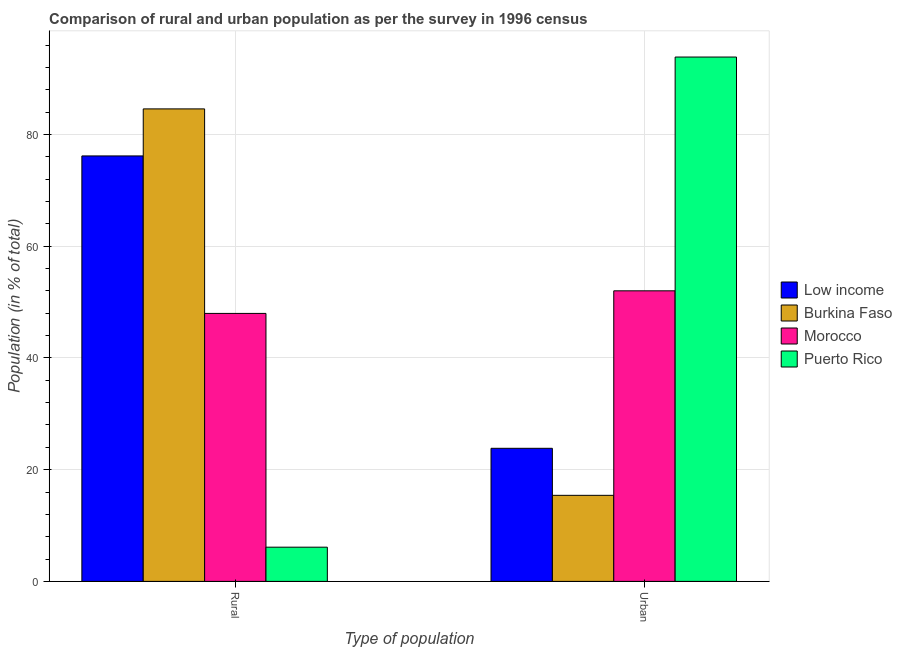How many different coloured bars are there?
Provide a succinct answer. 4. Are the number of bars per tick equal to the number of legend labels?
Offer a very short reply. Yes. Are the number of bars on each tick of the X-axis equal?
Ensure brevity in your answer.  Yes. How many bars are there on the 1st tick from the right?
Your answer should be compact. 4. What is the label of the 2nd group of bars from the left?
Offer a very short reply. Urban. What is the rural population in Puerto Rico?
Your response must be concise. 6.12. Across all countries, what is the maximum rural population?
Offer a terse response. 84.59. Across all countries, what is the minimum urban population?
Keep it short and to the point. 15.41. In which country was the rural population maximum?
Your answer should be compact. Burkina Faso. In which country was the rural population minimum?
Your answer should be very brief. Puerto Rico. What is the total urban population in the graph?
Your response must be concise. 185.13. What is the difference between the urban population in Low income and that in Burkina Faso?
Provide a short and direct response. 8.42. What is the difference between the urban population in Puerto Rico and the rural population in Low income?
Offer a very short reply. 17.7. What is the average urban population per country?
Offer a terse response. 46.28. What is the difference between the rural population and urban population in Morocco?
Give a very brief answer. -4.04. What is the ratio of the rural population in Morocco to that in Low income?
Keep it short and to the point. 0.63. In how many countries, is the rural population greater than the average rural population taken over all countries?
Make the answer very short. 2. What does the 2nd bar from the left in Rural represents?
Ensure brevity in your answer.  Burkina Faso. How many bars are there?
Ensure brevity in your answer.  8. Are all the bars in the graph horizontal?
Ensure brevity in your answer.  No. Are the values on the major ticks of Y-axis written in scientific E-notation?
Your answer should be compact. No. Does the graph contain any zero values?
Your answer should be very brief. No. Does the graph contain grids?
Ensure brevity in your answer.  Yes. Where does the legend appear in the graph?
Your answer should be very brief. Center right. What is the title of the graph?
Make the answer very short. Comparison of rural and urban population as per the survey in 1996 census. Does "Central African Republic" appear as one of the legend labels in the graph?
Give a very brief answer. No. What is the label or title of the X-axis?
Provide a succinct answer. Type of population. What is the label or title of the Y-axis?
Keep it short and to the point. Population (in % of total). What is the Population (in % of total) of Low income in Rural?
Make the answer very short. 76.17. What is the Population (in % of total) of Burkina Faso in Rural?
Your answer should be compact. 84.59. What is the Population (in % of total) in Morocco in Rural?
Offer a terse response. 47.98. What is the Population (in % of total) in Puerto Rico in Rural?
Provide a short and direct response. 6.12. What is the Population (in % of total) of Low income in Urban?
Provide a succinct answer. 23.83. What is the Population (in % of total) in Burkina Faso in Urban?
Make the answer very short. 15.41. What is the Population (in % of total) of Morocco in Urban?
Keep it short and to the point. 52.02. What is the Population (in % of total) of Puerto Rico in Urban?
Your answer should be very brief. 93.88. Across all Type of population, what is the maximum Population (in % of total) in Low income?
Offer a very short reply. 76.17. Across all Type of population, what is the maximum Population (in % of total) of Burkina Faso?
Offer a very short reply. 84.59. Across all Type of population, what is the maximum Population (in % of total) in Morocco?
Ensure brevity in your answer.  52.02. Across all Type of population, what is the maximum Population (in % of total) of Puerto Rico?
Ensure brevity in your answer.  93.88. Across all Type of population, what is the minimum Population (in % of total) in Low income?
Your answer should be very brief. 23.83. Across all Type of population, what is the minimum Population (in % of total) of Burkina Faso?
Give a very brief answer. 15.41. Across all Type of population, what is the minimum Population (in % of total) of Morocco?
Ensure brevity in your answer.  47.98. Across all Type of population, what is the minimum Population (in % of total) in Puerto Rico?
Ensure brevity in your answer.  6.12. What is the total Population (in % of total) in Burkina Faso in the graph?
Keep it short and to the point. 100. What is the difference between the Population (in % of total) of Low income in Rural and that in Urban?
Offer a very short reply. 52.35. What is the difference between the Population (in % of total) in Burkina Faso in Rural and that in Urban?
Offer a terse response. 69.19. What is the difference between the Population (in % of total) in Morocco in Rural and that in Urban?
Your answer should be very brief. -4.04. What is the difference between the Population (in % of total) in Puerto Rico in Rural and that in Urban?
Your answer should be compact. -87.75. What is the difference between the Population (in % of total) in Low income in Rural and the Population (in % of total) in Burkina Faso in Urban?
Your response must be concise. 60.77. What is the difference between the Population (in % of total) of Low income in Rural and the Population (in % of total) of Morocco in Urban?
Provide a succinct answer. 24.15. What is the difference between the Population (in % of total) in Low income in Rural and the Population (in % of total) in Puerto Rico in Urban?
Ensure brevity in your answer.  -17.7. What is the difference between the Population (in % of total) of Burkina Faso in Rural and the Population (in % of total) of Morocco in Urban?
Provide a short and direct response. 32.57. What is the difference between the Population (in % of total) in Burkina Faso in Rural and the Population (in % of total) in Puerto Rico in Urban?
Keep it short and to the point. -9.28. What is the difference between the Population (in % of total) in Morocco in Rural and the Population (in % of total) in Puerto Rico in Urban?
Provide a short and direct response. -45.9. What is the average Population (in % of total) of Burkina Faso per Type of population?
Ensure brevity in your answer.  50. What is the average Population (in % of total) in Morocco per Type of population?
Your answer should be compact. 50. What is the difference between the Population (in % of total) of Low income and Population (in % of total) of Burkina Faso in Rural?
Offer a terse response. -8.42. What is the difference between the Population (in % of total) of Low income and Population (in % of total) of Morocco in Rural?
Provide a short and direct response. 28.19. What is the difference between the Population (in % of total) of Low income and Population (in % of total) of Puerto Rico in Rural?
Provide a succinct answer. 70.05. What is the difference between the Population (in % of total) of Burkina Faso and Population (in % of total) of Morocco in Rural?
Provide a succinct answer. 36.62. What is the difference between the Population (in % of total) in Burkina Faso and Population (in % of total) in Puerto Rico in Rural?
Keep it short and to the point. 78.47. What is the difference between the Population (in % of total) in Morocco and Population (in % of total) in Puerto Rico in Rural?
Your response must be concise. 41.85. What is the difference between the Population (in % of total) of Low income and Population (in % of total) of Burkina Faso in Urban?
Provide a short and direct response. 8.42. What is the difference between the Population (in % of total) of Low income and Population (in % of total) of Morocco in Urban?
Keep it short and to the point. -28.19. What is the difference between the Population (in % of total) in Low income and Population (in % of total) in Puerto Rico in Urban?
Offer a very short reply. -70.05. What is the difference between the Population (in % of total) in Burkina Faso and Population (in % of total) in Morocco in Urban?
Your answer should be very brief. -36.62. What is the difference between the Population (in % of total) in Burkina Faso and Population (in % of total) in Puerto Rico in Urban?
Make the answer very short. -78.47. What is the difference between the Population (in % of total) of Morocco and Population (in % of total) of Puerto Rico in Urban?
Ensure brevity in your answer.  -41.85. What is the ratio of the Population (in % of total) of Low income in Rural to that in Urban?
Make the answer very short. 3.2. What is the ratio of the Population (in % of total) of Burkina Faso in Rural to that in Urban?
Offer a very short reply. 5.49. What is the ratio of the Population (in % of total) in Morocco in Rural to that in Urban?
Your answer should be compact. 0.92. What is the ratio of the Population (in % of total) of Puerto Rico in Rural to that in Urban?
Offer a very short reply. 0.07. What is the difference between the highest and the second highest Population (in % of total) in Low income?
Keep it short and to the point. 52.35. What is the difference between the highest and the second highest Population (in % of total) in Burkina Faso?
Offer a terse response. 69.19. What is the difference between the highest and the second highest Population (in % of total) of Morocco?
Ensure brevity in your answer.  4.04. What is the difference between the highest and the second highest Population (in % of total) in Puerto Rico?
Ensure brevity in your answer.  87.75. What is the difference between the highest and the lowest Population (in % of total) in Low income?
Make the answer very short. 52.35. What is the difference between the highest and the lowest Population (in % of total) of Burkina Faso?
Your response must be concise. 69.19. What is the difference between the highest and the lowest Population (in % of total) of Morocco?
Keep it short and to the point. 4.04. What is the difference between the highest and the lowest Population (in % of total) of Puerto Rico?
Keep it short and to the point. 87.75. 